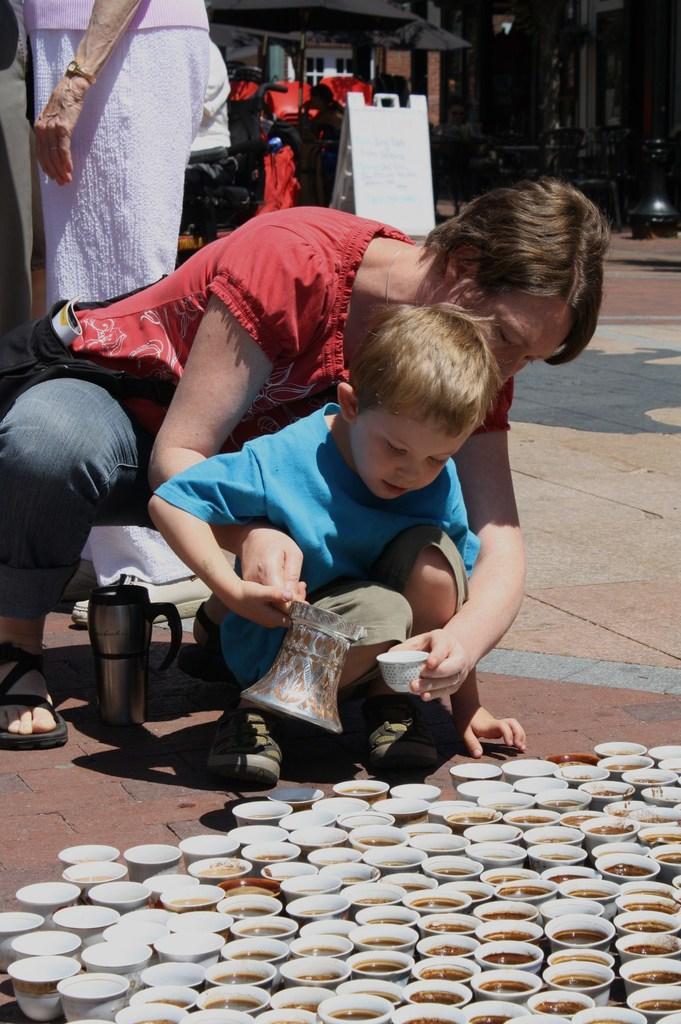Please provide a concise description of this image. In the image we can see there are people and a child, wearing clothes. There are many cups, a jug, slippers, footpath, board and pole. We can even see the building and this is a wrist watch. 